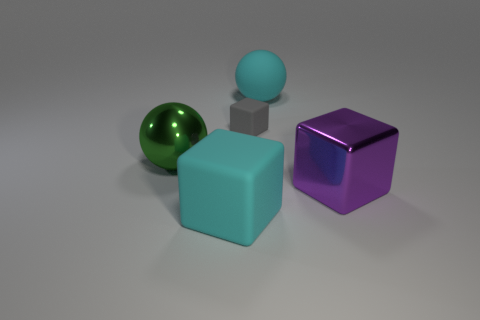There is a ball that is made of the same material as the gray block; what size is it?
Give a very brief answer. Large. Is there any other thing of the same color as the metal block?
Offer a very short reply. No. Is the big cyan ball made of the same material as the large cyan object in front of the large cyan ball?
Your answer should be compact. Yes. What material is the purple object that is the same shape as the gray thing?
Ensure brevity in your answer.  Metal. Are there any other things that have the same material as the large purple block?
Ensure brevity in your answer.  Yes. Is the material of the large ball that is to the right of the big metallic ball the same as the big ball in front of the tiny matte object?
Ensure brevity in your answer.  No. The object left of the large cyan object to the left of the cyan matte object that is behind the small gray cube is what color?
Offer a terse response. Green. What number of other things are the same shape as the small object?
Make the answer very short. 2. Do the big shiny sphere and the metal cube have the same color?
Provide a succinct answer. No. What number of objects are large cyan cubes or cyan things that are behind the large cyan rubber cube?
Offer a very short reply. 2. 